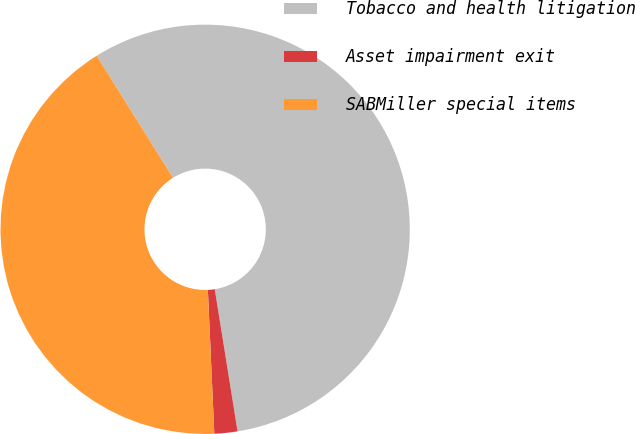Convert chart. <chart><loc_0><loc_0><loc_500><loc_500><pie_chart><fcel>Tobacco and health litigation<fcel>Asset impairment exit<fcel>SABMiller special items<nl><fcel>56.36%<fcel>1.82%<fcel>41.82%<nl></chart> 